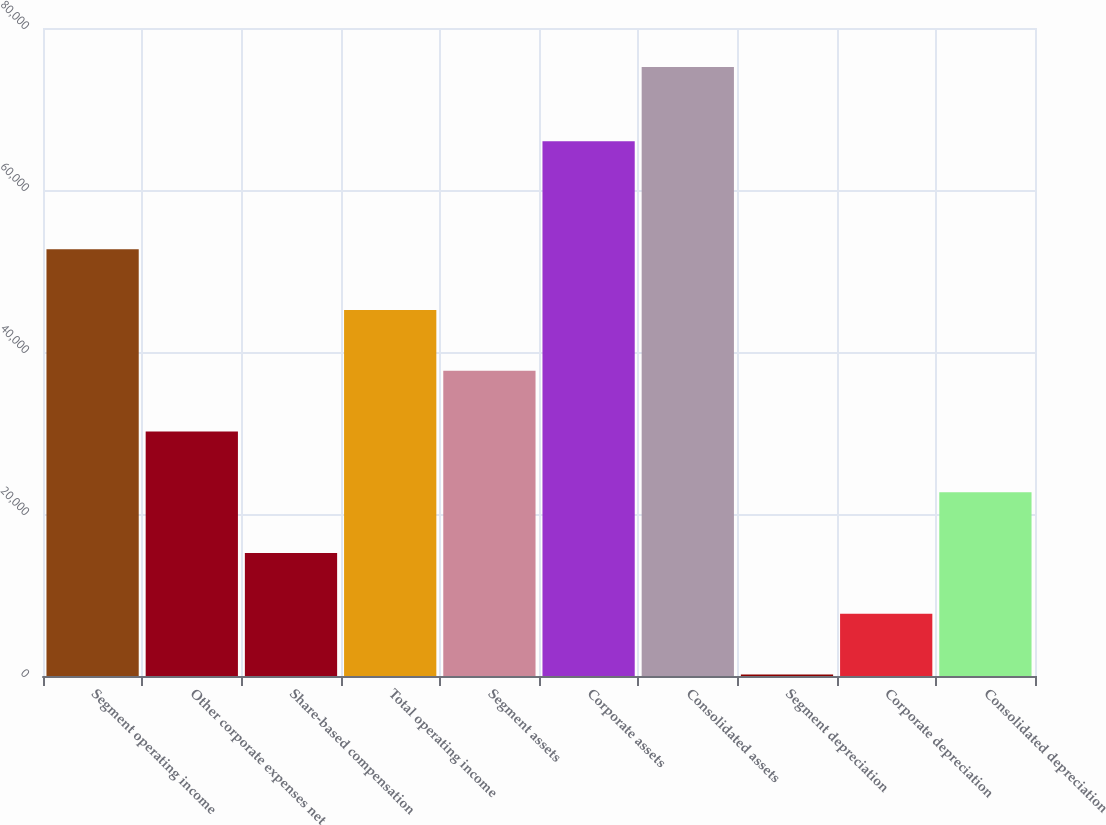Convert chart to OTSL. <chart><loc_0><loc_0><loc_500><loc_500><bar_chart><fcel>Segment operating income<fcel>Other corporate expenses net<fcel>Share-based compensation<fcel>Total operating income<fcel>Segment assets<fcel>Corporate assets<fcel>Consolidated assets<fcel>Segment depreciation<fcel>Corporate depreciation<fcel>Consolidated depreciation<nl><fcel>52685.1<fcel>30187.2<fcel>15188.6<fcel>45185.8<fcel>37686.5<fcel>66006<fcel>75183<fcel>190<fcel>7689.3<fcel>22687.9<nl></chart> 